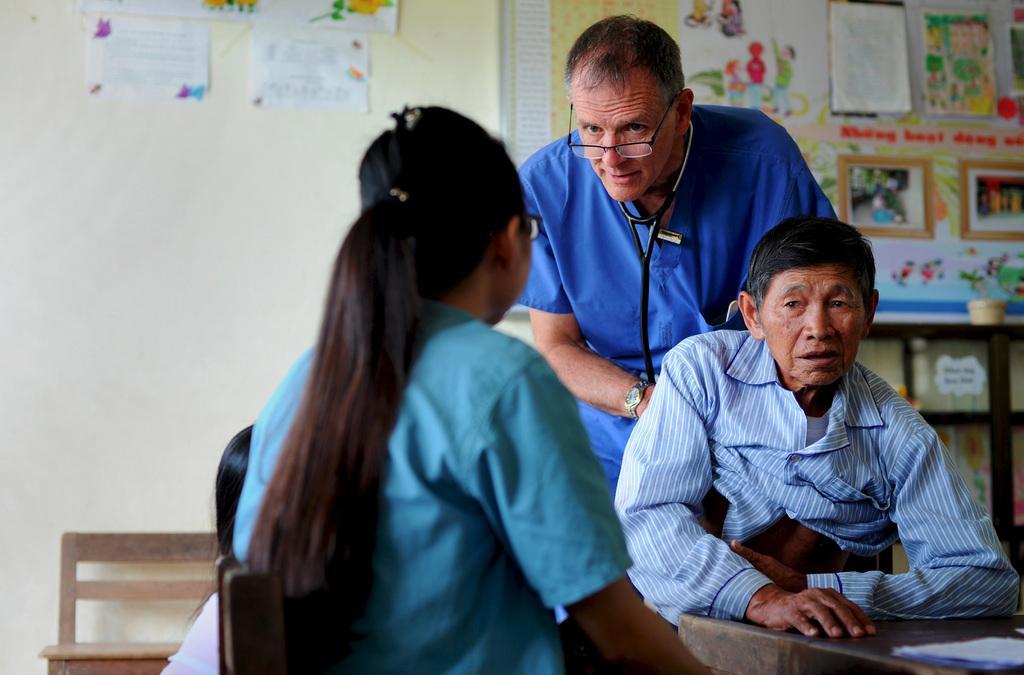Please provide a concise description of this image. There is a doctor talking to a girl and giving treatment to a man. 